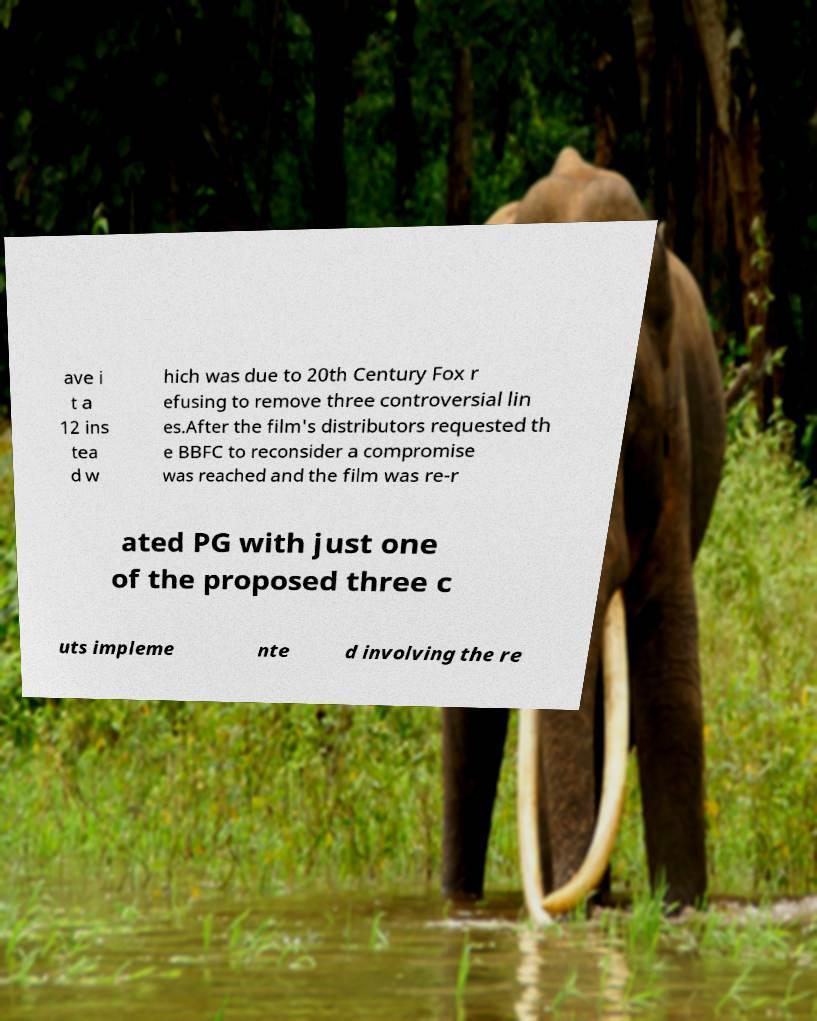For documentation purposes, I need the text within this image transcribed. Could you provide that? ave i t a 12 ins tea d w hich was due to 20th Century Fox r efusing to remove three controversial lin es.After the film's distributors requested th e BBFC to reconsider a compromise was reached and the film was re-r ated PG with just one of the proposed three c uts impleme nte d involving the re 